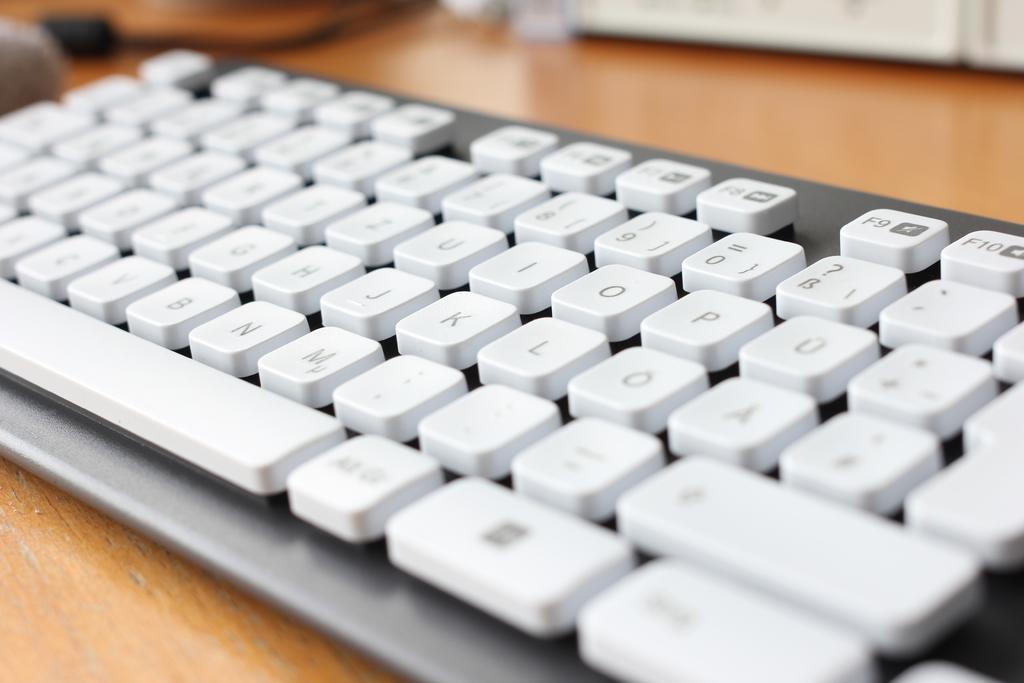In one or two sentences, can you explain what this image depicts? This is the picture of a keyboard on which the things are in white color. 